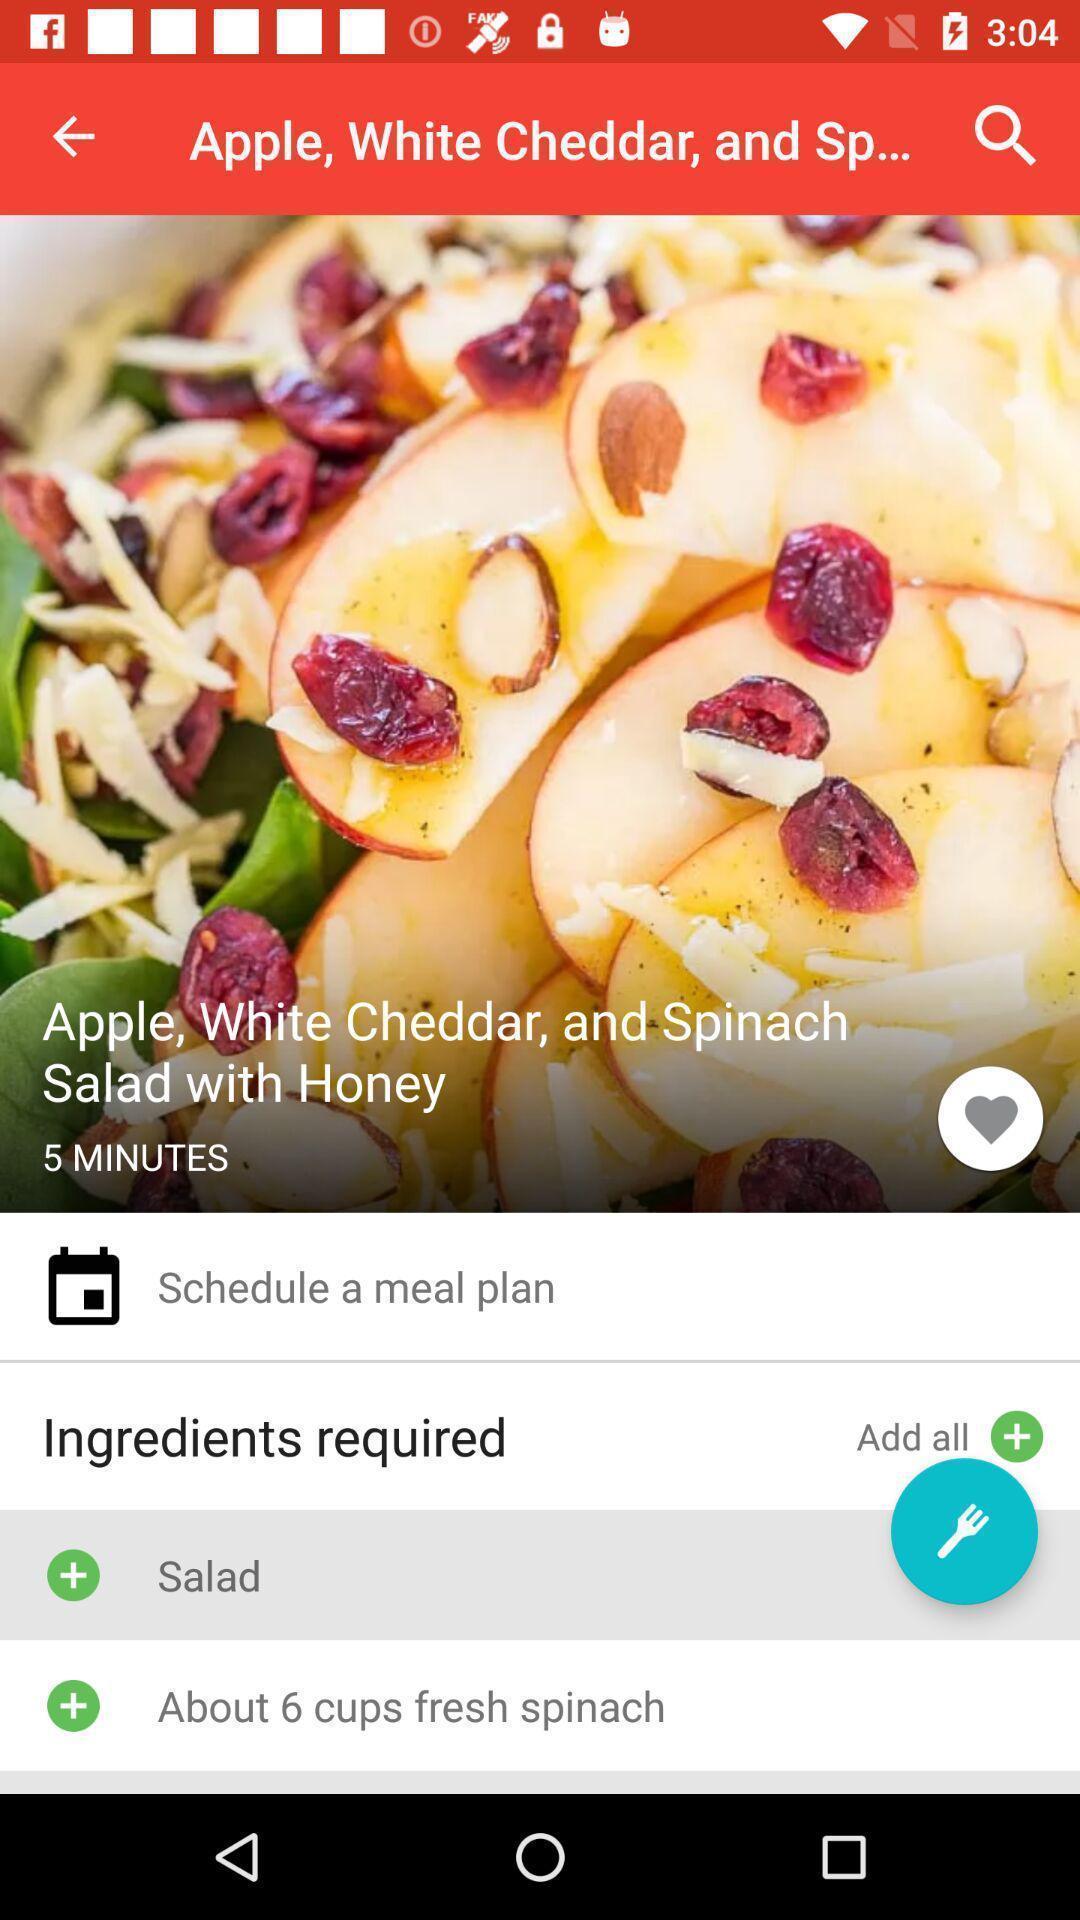Describe the key features of this screenshot. Screen shows ingredients required in a food application. 